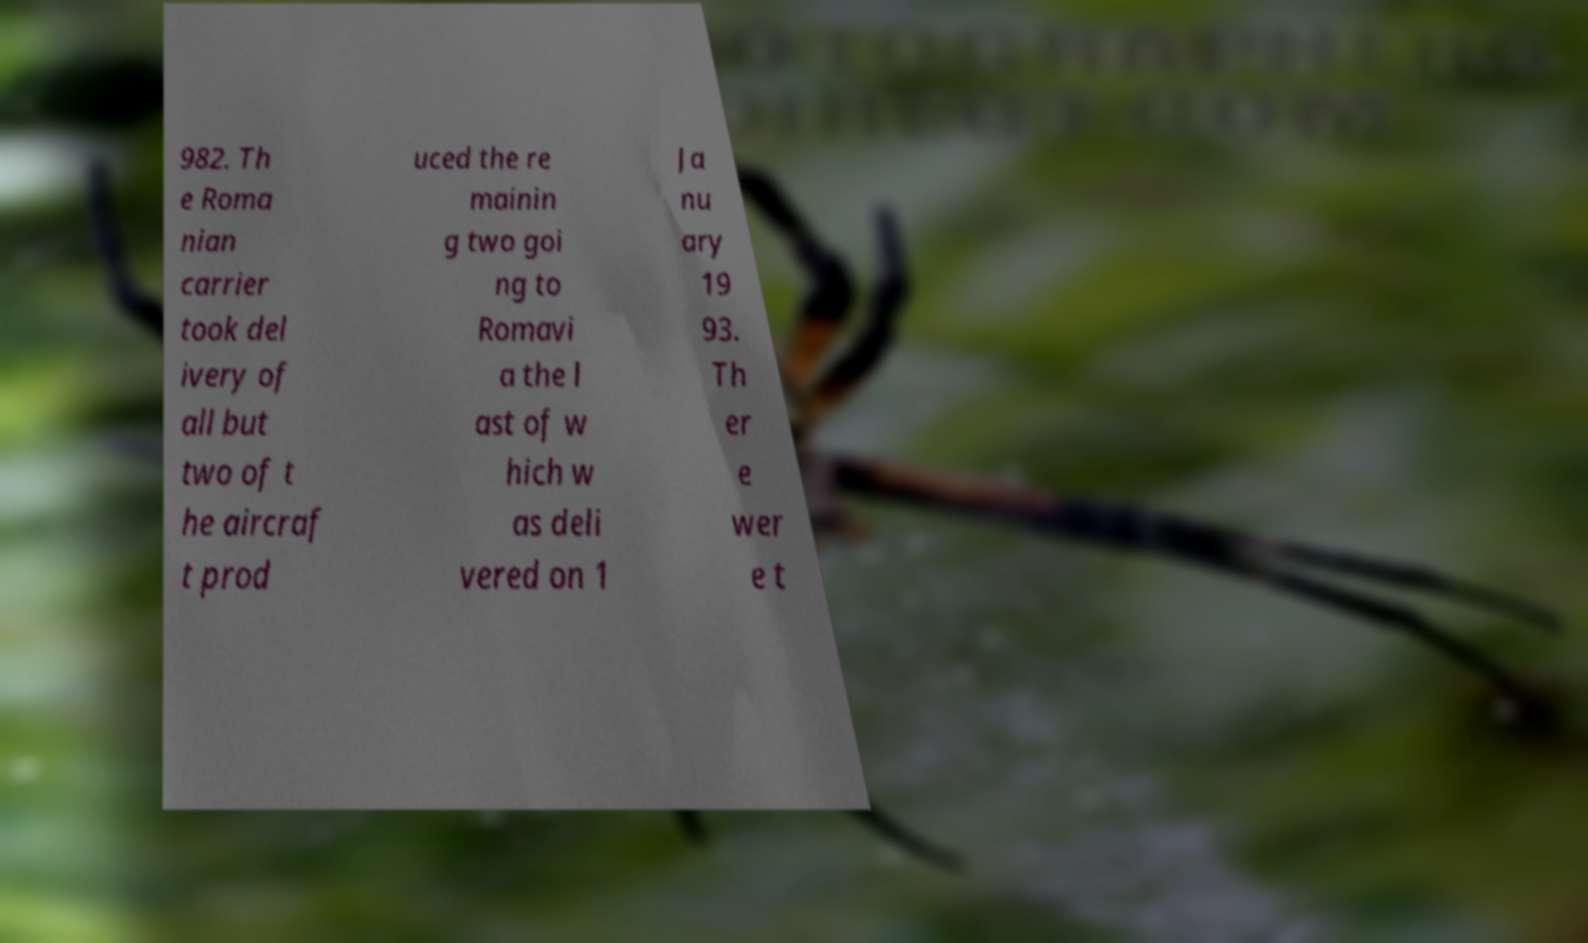Can you read and provide the text displayed in the image?This photo seems to have some interesting text. Can you extract and type it out for me? 982. Th e Roma nian carrier took del ivery of all but two of t he aircraf t prod uced the re mainin g two goi ng to Romavi a the l ast of w hich w as deli vered on 1 Ja nu ary 19 93. Th er e wer e t 